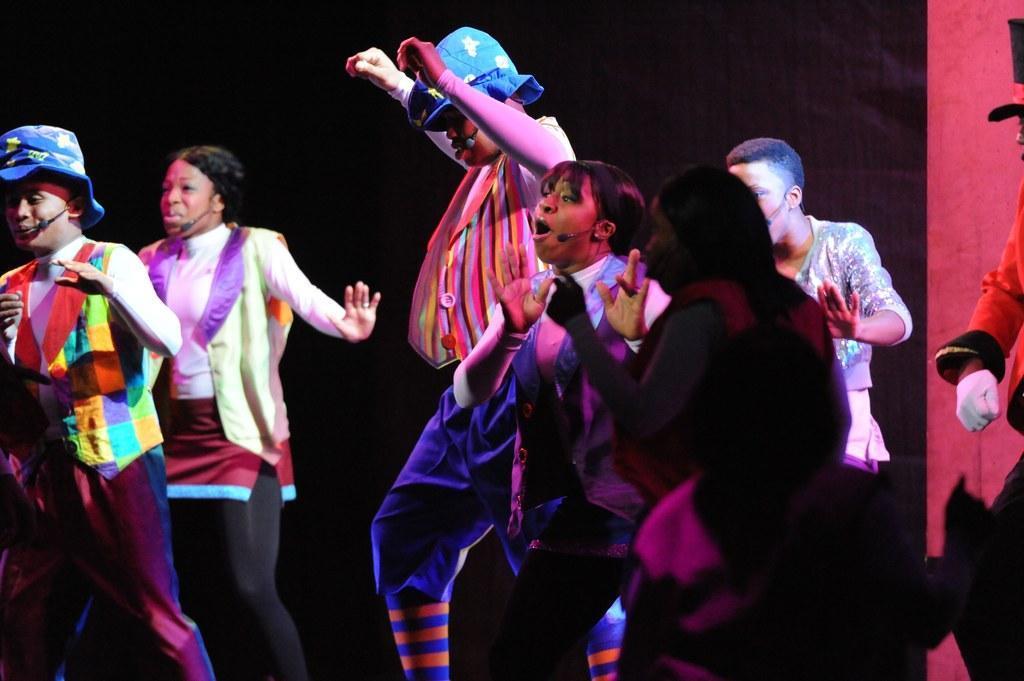Please provide a concise description of this image. In this image we can see there are people dancing and singing and there's the dark background. 